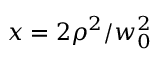Convert formula to latex. <formula><loc_0><loc_0><loc_500><loc_500>x = 2 \rho ^ { 2 } / w _ { 0 } ^ { 2 }</formula> 